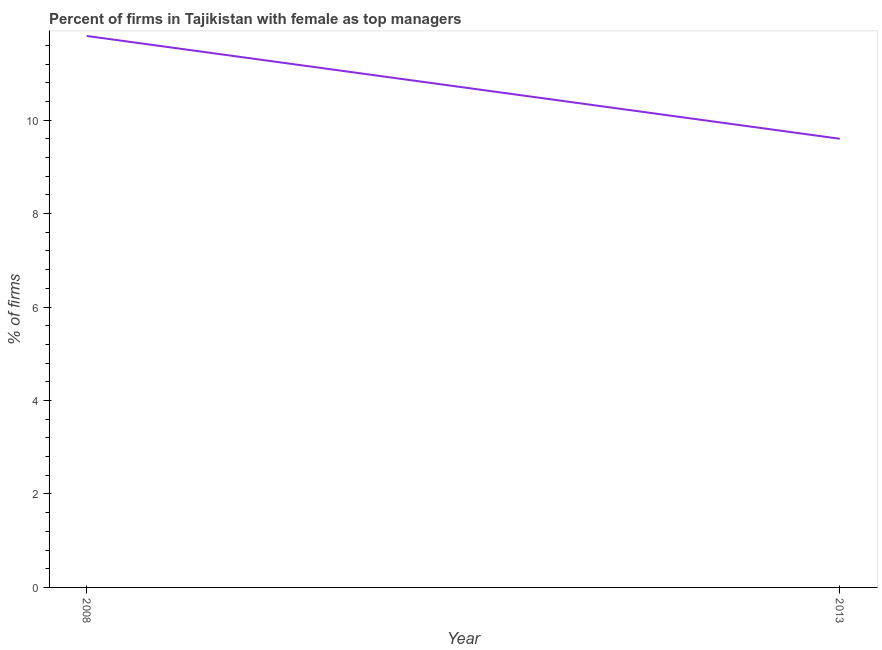What is the percentage of firms with female as top manager in 2013?
Your answer should be very brief. 9.6. Across all years, what is the minimum percentage of firms with female as top manager?
Offer a very short reply. 9.6. What is the sum of the percentage of firms with female as top manager?
Keep it short and to the point. 21.4. What is the difference between the percentage of firms with female as top manager in 2008 and 2013?
Keep it short and to the point. 2.2. What is the median percentage of firms with female as top manager?
Offer a very short reply. 10.7. Do a majority of the years between 2013 and 2008 (inclusive) have percentage of firms with female as top manager greater than 5.6 %?
Offer a terse response. No. What is the ratio of the percentage of firms with female as top manager in 2008 to that in 2013?
Keep it short and to the point. 1.23. In how many years, is the percentage of firms with female as top manager greater than the average percentage of firms with female as top manager taken over all years?
Your response must be concise. 1. How many lines are there?
Offer a very short reply. 1. What is the difference between two consecutive major ticks on the Y-axis?
Your answer should be very brief. 2. What is the title of the graph?
Your answer should be compact. Percent of firms in Tajikistan with female as top managers. What is the label or title of the X-axis?
Your answer should be compact. Year. What is the label or title of the Y-axis?
Your answer should be very brief. % of firms. What is the % of firms of 2008?
Your response must be concise. 11.8. What is the % of firms of 2013?
Give a very brief answer. 9.6. What is the difference between the % of firms in 2008 and 2013?
Your answer should be very brief. 2.2. What is the ratio of the % of firms in 2008 to that in 2013?
Offer a very short reply. 1.23. 